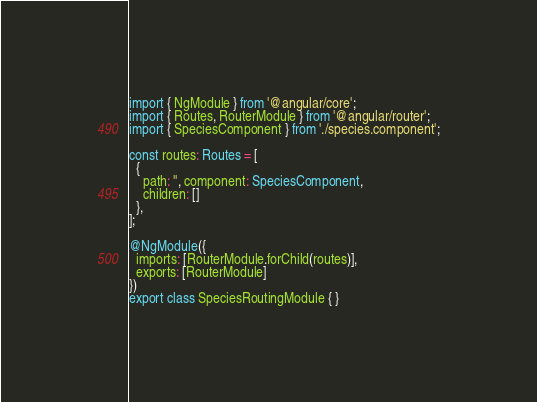Convert code to text. <code><loc_0><loc_0><loc_500><loc_500><_TypeScript_>import { NgModule } from '@angular/core';
import { Routes, RouterModule } from '@angular/router';
import { SpeciesComponent } from './species.component';

const routes: Routes = [
  {
    path: '', component: SpeciesComponent,
    children: []
  },
];

@NgModule({
  imports: [RouterModule.forChild(routes)],
  exports: [RouterModule]
})
export class SpeciesRoutingModule { }
</code> 